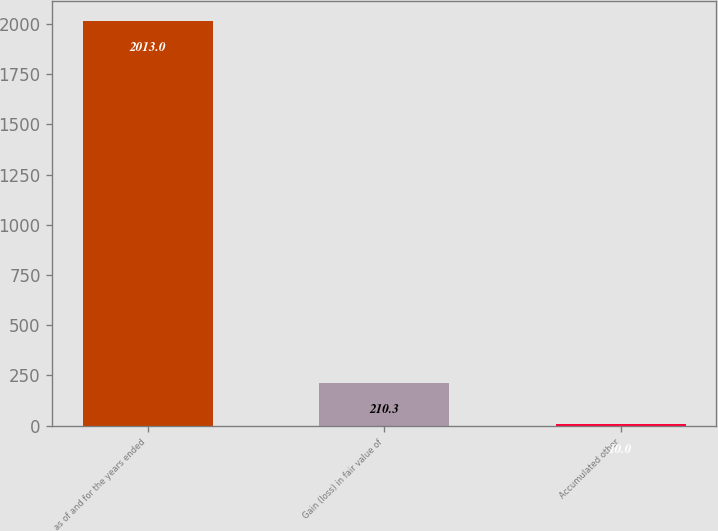Convert chart. <chart><loc_0><loc_0><loc_500><loc_500><bar_chart><fcel>as of and for the years ended<fcel>Gain (loss) in fair value of<fcel>Accumulated other<nl><fcel>2013<fcel>210.3<fcel>10<nl></chart> 